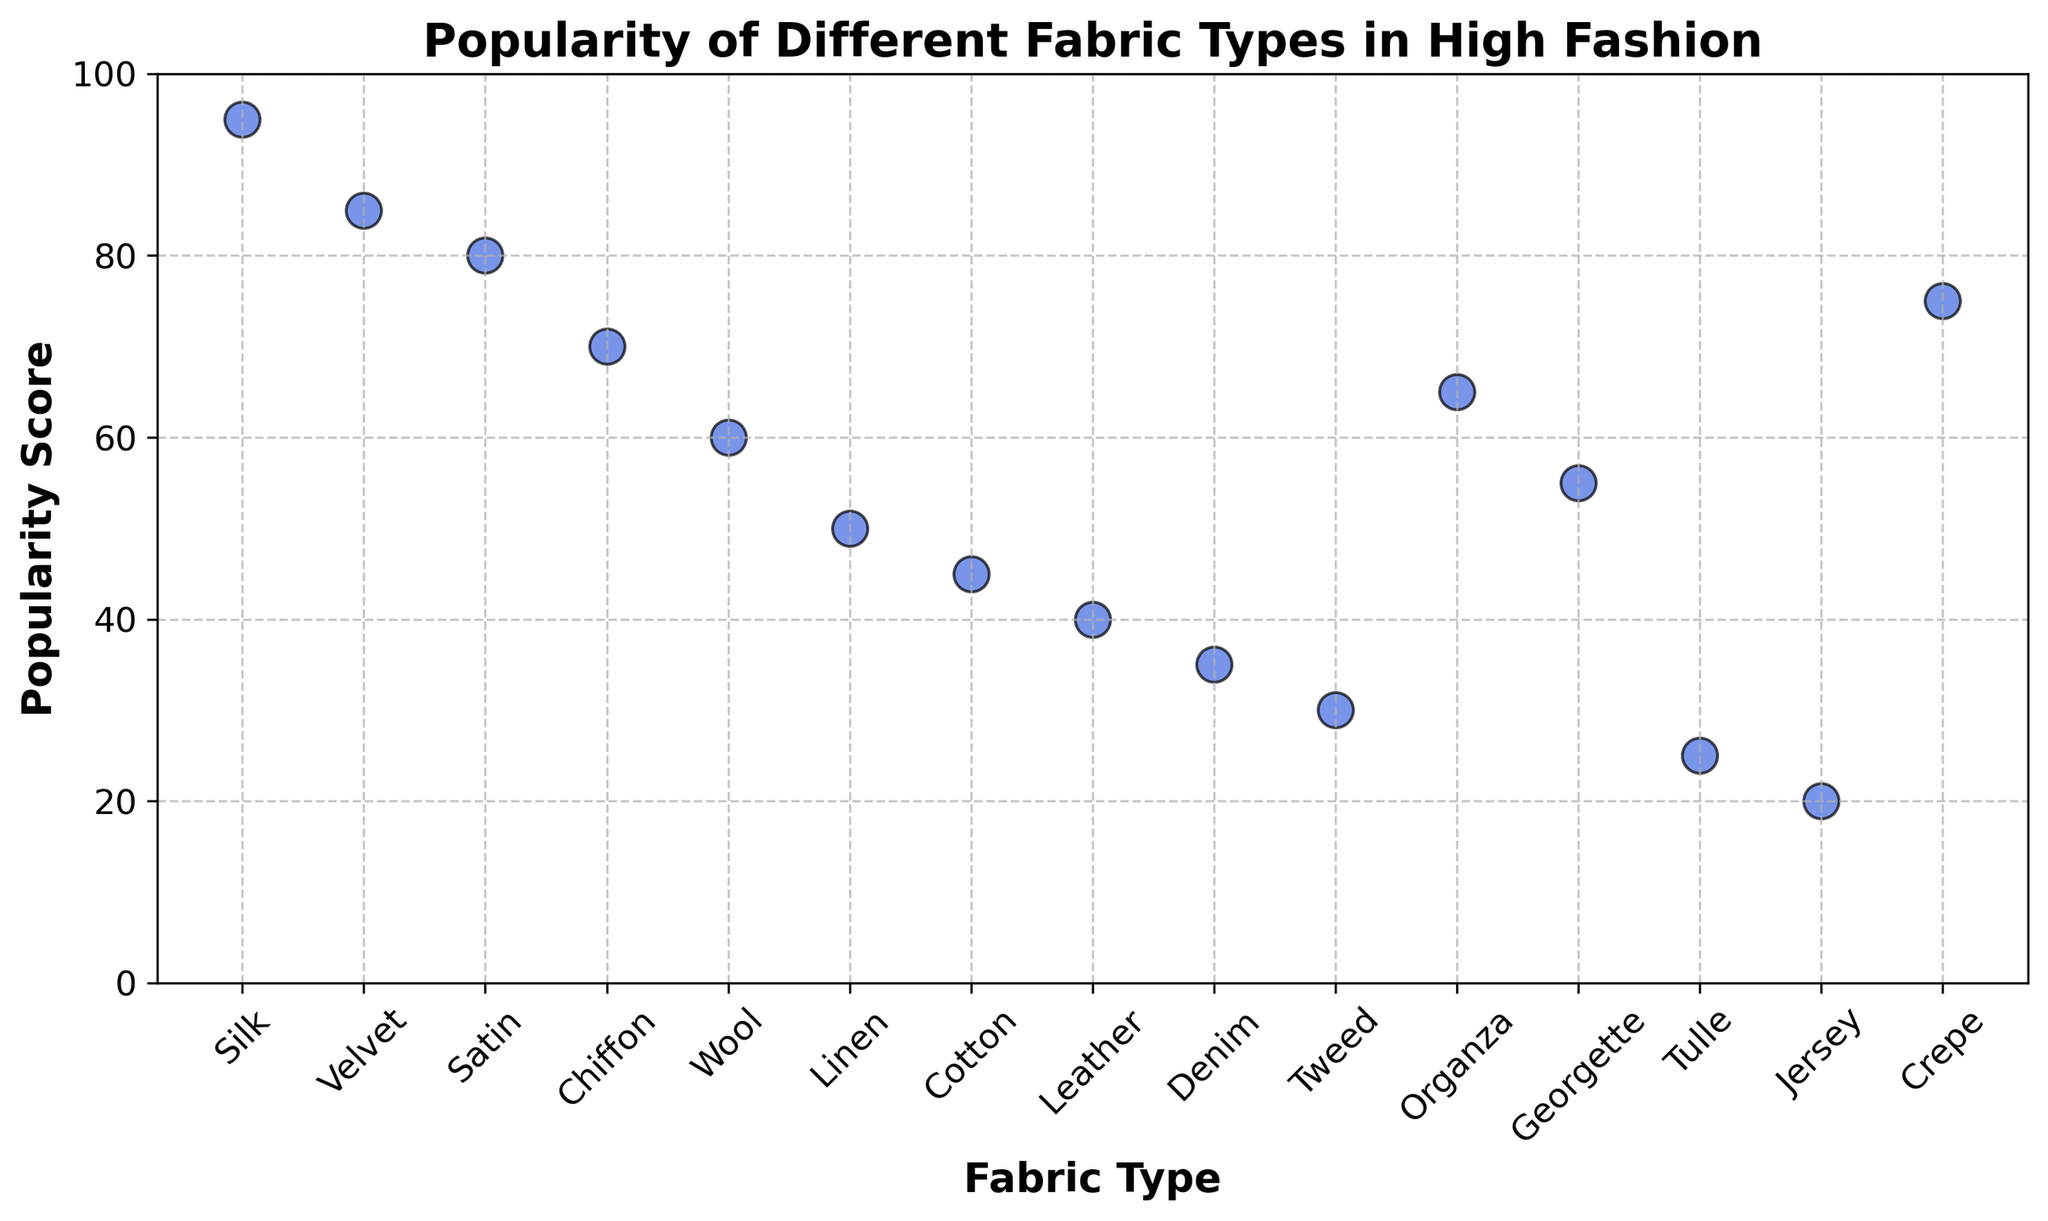What fabric type has the highest popularity score? Observe the scatter plot for the data point with the highest y-axis value, which represents the popularity score.
Answer: Silk Which fabric type has the lowest popularity score? Look at the scatter plot for the data point with the lowest y-axis value.
Answer: Jersey What is the difference in popularity score between Silk and Wool? Find the popularity scores for Silk and Wool on the y-axis. Silk has a score of 95, and Wool has a score of 60. The difference is 95 - 60.
Answer: 35 What is the average popularity score of Silk, Velvet, and Satin? Sum the popularity scores of Silk (95), Velvet (85), and Satin (80) and then divide by the number of fabrics. (95 + 85 + 80) / 3.
Answer: 86.67 Which fabric types have a popularity score greater than 80? Identify the data points with y-axis values above 80. Silk and Velvet qualify.
Answer: Silk, Velvet Which fabric type has a popularity score closest to 50? Check the y-axis values and find the data point that is nearest to 50. Linen has a score of 50.
Answer: Linen How many fabric types have a popularity score less than 40? Count the data points with y-axis values below 40. Denim, Tulle, and Jersey fit this criterion.
Answer: 3 What is the median popularity score of all the fabric types? Arrange the popularity scores in ascending order and find the middle value. The middle value for 15 data points is the 8th score when sorted. The sorted values are 20, 25, 30, 35, 40, 45, 50, 55, 60, 65, 70, 75, 80, 85, 95. The 8th score is 55.
Answer: 55 How does the popularity score of Chiffon compare to that of Linen? Identify the y-axis values for Chiffon and Linen. Chiffon has a score of 70 and Linen has a score of 50. Comparing these values, Chiffon has a higher score.
Answer: Chiffon is higher How many fabric types have a popularity score in the range between 60 and 80 (inclusive)? Count the data points with y-axis values between 60 and 80, including the endpoints. Wool (60), Organza (65), Crepe (75), and Satin (80) are within this range.
Answer: 4 